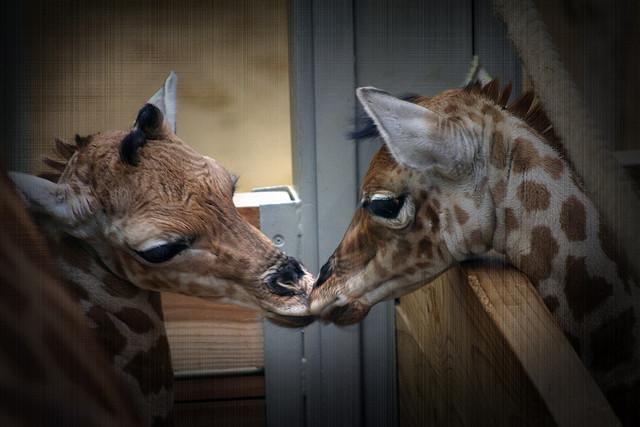How many giraffes are in the picture?
Give a very brief answer. 2. 